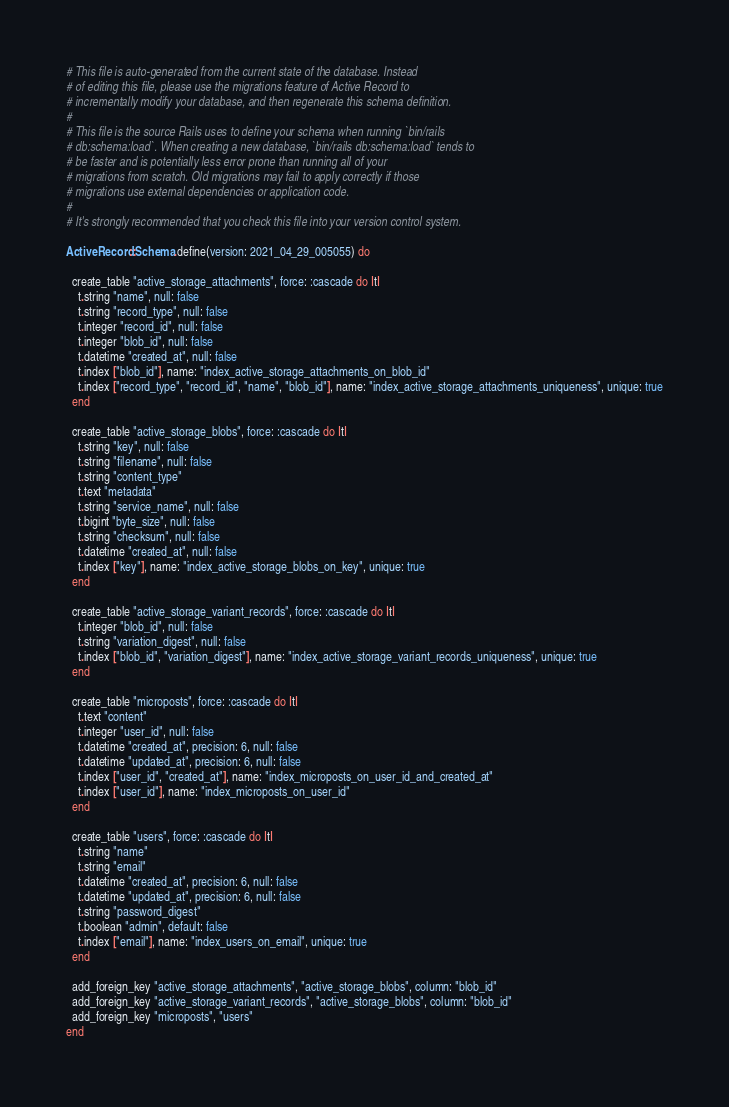<code> <loc_0><loc_0><loc_500><loc_500><_Ruby_># This file is auto-generated from the current state of the database. Instead
# of editing this file, please use the migrations feature of Active Record to
# incrementally modify your database, and then regenerate this schema definition.
#
# This file is the source Rails uses to define your schema when running `bin/rails
# db:schema:load`. When creating a new database, `bin/rails db:schema:load` tends to
# be faster and is potentially less error prone than running all of your
# migrations from scratch. Old migrations may fail to apply correctly if those
# migrations use external dependencies or application code.
#
# It's strongly recommended that you check this file into your version control system.

ActiveRecord::Schema.define(version: 2021_04_29_005055) do

  create_table "active_storage_attachments", force: :cascade do |t|
    t.string "name", null: false
    t.string "record_type", null: false
    t.integer "record_id", null: false
    t.integer "blob_id", null: false
    t.datetime "created_at", null: false
    t.index ["blob_id"], name: "index_active_storage_attachments_on_blob_id"
    t.index ["record_type", "record_id", "name", "blob_id"], name: "index_active_storage_attachments_uniqueness", unique: true
  end

  create_table "active_storage_blobs", force: :cascade do |t|
    t.string "key", null: false
    t.string "filename", null: false
    t.string "content_type"
    t.text "metadata"
    t.string "service_name", null: false
    t.bigint "byte_size", null: false
    t.string "checksum", null: false
    t.datetime "created_at", null: false
    t.index ["key"], name: "index_active_storage_blobs_on_key", unique: true
  end

  create_table "active_storage_variant_records", force: :cascade do |t|
    t.integer "blob_id", null: false
    t.string "variation_digest", null: false
    t.index ["blob_id", "variation_digest"], name: "index_active_storage_variant_records_uniqueness", unique: true
  end

  create_table "microposts", force: :cascade do |t|
    t.text "content"
    t.integer "user_id", null: false
    t.datetime "created_at", precision: 6, null: false
    t.datetime "updated_at", precision: 6, null: false
    t.index ["user_id", "created_at"], name: "index_microposts_on_user_id_and_created_at"
    t.index ["user_id"], name: "index_microposts_on_user_id"
  end

  create_table "users", force: :cascade do |t|
    t.string "name"
    t.string "email"
    t.datetime "created_at", precision: 6, null: false
    t.datetime "updated_at", precision: 6, null: false
    t.string "password_digest"
    t.boolean "admin", default: false
    t.index ["email"], name: "index_users_on_email", unique: true
  end

  add_foreign_key "active_storage_attachments", "active_storage_blobs", column: "blob_id"
  add_foreign_key "active_storage_variant_records", "active_storage_blobs", column: "blob_id"
  add_foreign_key "microposts", "users"
end
</code> 